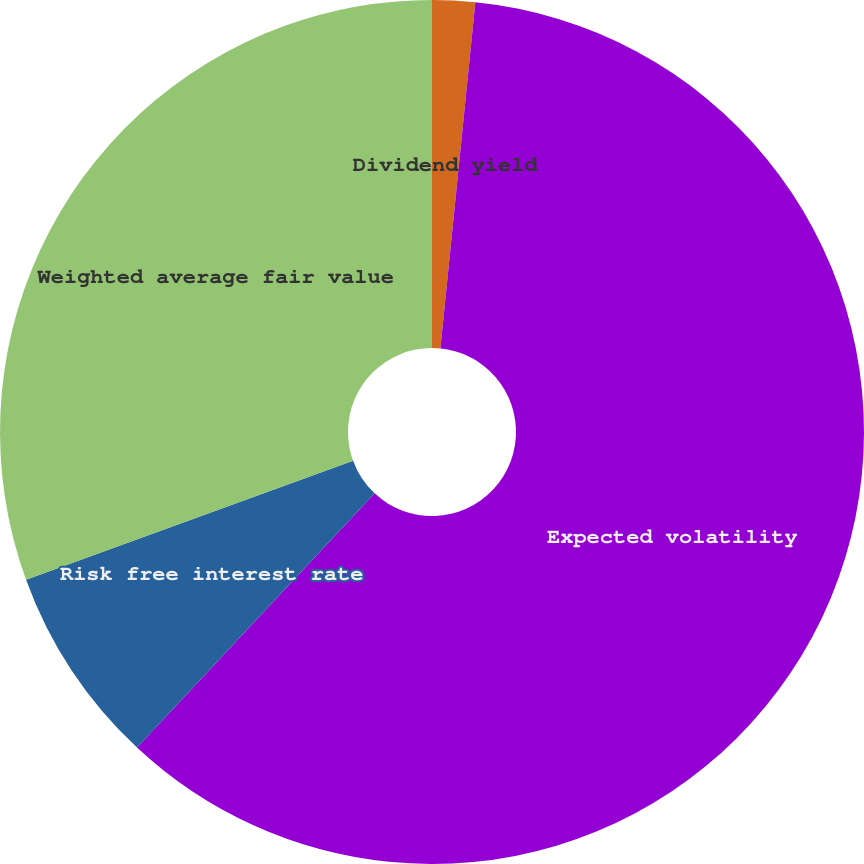Convert chart. <chart><loc_0><loc_0><loc_500><loc_500><pie_chart><fcel>Dividend yield<fcel>Expected volatility<fcel>Risk free interest rate<fcel>Weighted average fair value<nl><fcel>1.6%<fcel>60.37%<fcel>7.48%<fcel>30.56%<nl></chart> 